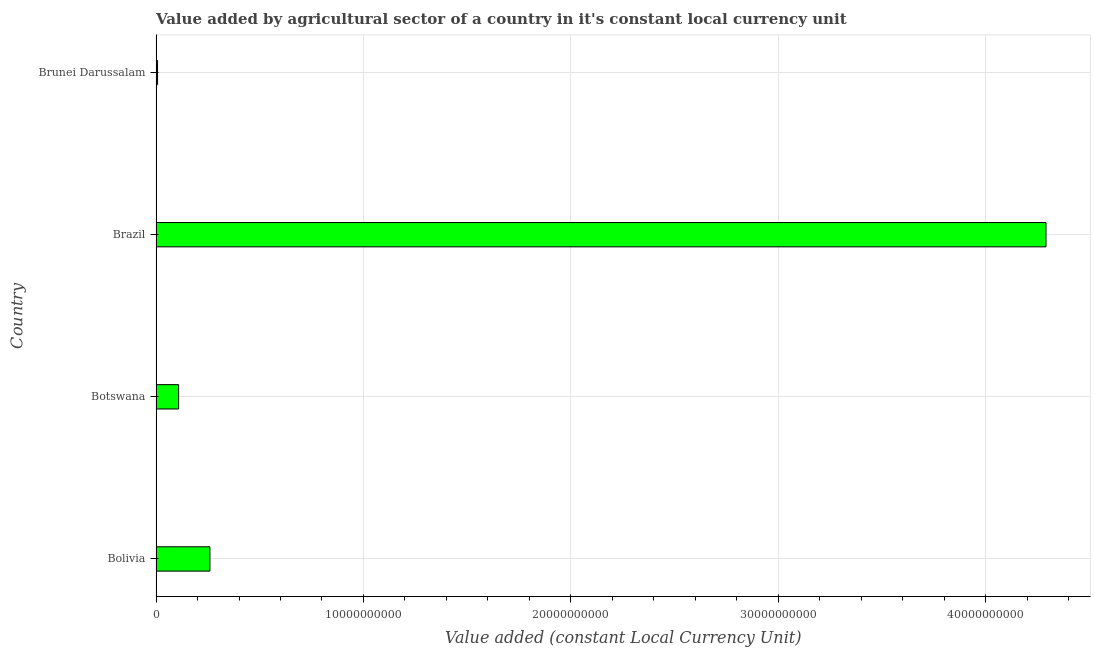What is the title of the graph?
Ensure brevity in your answer.  Value added by agricultural sector of a country in it's constant local currency unit. What is the label or title of the X-axis?
Ensure brevity in your answer.  Value added (constant Local Currency Unit). What is the label or title of the Y-axis?
Provide a succinct answer. Country. What is the value added by agriculture sector in Bolivia?
Provide a short and direct response. 2.60e+09. Across all countries, what is the maximum value added by agriculture sector?
Give a very brief answer. 4.29e+1. Across all countries, what is the minimum value added by agriculture sector?
Provide a succinct answer. 7.34e+07. In which country was the value added by agriculture sector minimum?
Your answer should be very brief. Brunei Darussalam. What is the sum of the value added by agriculture sector?
Your answer should be compact. 4.67e+1. What is the difference between the value added by agriculture sector in Brazil and Brunei Darussalam?
Ensure brevity in your answer.  4.28e+1. What is the average value added by agriculture sector per country?
Provide a succinct answer. 1.17e+1. What is the median value added by agriculture sector?
Your answer should be very brief. 1.84e+09. In how many countries, is the value added by agriculture sector greater than 20000000000 LCU?
Keep it short and to the point. 1. What is the ratio of the value added by agriculture sector in Botswana to that in Brazil?
Ensure brevity in your answer.  0.03. What is the difference between the highest and the second highest value added by agriculture sector?
Provide a succinct answer. 4.03e+1. What is the difference between the highest and the lowest value added by agriculture sector?
Your response must be concise. 4.28e+1. In how many countries, is the value added by agriculture sector greater than the average value added by agriculture sector taken over all countries?
Provide a succinct answer. 1. How many bars are there?
Keep it short and to the point. 4. Are the values on the major ticks of X-axis written in scientific E-notation?
Your answer should be very brief. No. What is the Value added (constant Local Currency Unit) in Bolivia?
Provide a short and direct response. 2.60e+09. What is the Value added (constant Local Currency Unit) of Botswana?
Provide a short and direct response. 1.09e+09. What is the Value added (constant Local Currency Unit) of Brazil?
Provide a succinct answer. 4.29e+1. What is the Value added (constant Local Currency Unit) of Brunei Darussalam?
Your response must be concise. 7.34e+07. What is the difference between the Value added (constant Local Currency Unit) in Bolivia and Botswana?
Make the answer very short. 1.51e+09. What is the difference between the Value added (constant Local Currency Unit) in Bolivia and Brazil?
Your answer should be compact. -4.03e+1. What is the difference between the Value added (constant Local Currency Unit) in Bolivia and Brunei Darussalam?
Offer a very short reply. 2.52e+09. What is the difference between the Value added (constant Local Currency Unit) in Botswana and Brazil?
Ensure brevity in your answer.  -4.18e+1. What is the difference between the Value added (constant Local Currency Unit) in Botswana and Brunei Darussalam?
Your answer should be compact. 1.02e+09. What is the difference between the Value added (constant Local Currency Unit) in Brazil and Brunei Darussalam?
Your answer should be very brief. 4.28e+1. What is the ratio of the Value added (constant Local Currency Unit) in Bolivia to that in Botswana?
Your answer should be compact. 2.38. What is the ratio of the Value added (constant Local Currency Unit) in Bolivia to that in Brazil?
Make the answer very short. 0.06. What is the ratio of the Value added (constant Local Currency Unit) in Bolivia to that in Brunei Darussalam?
Offer a very short reply. 35.4. What is the ratio of the Value added (constant Local Currency Unit) in Botswana to that in Brazil?
Ensure brevity in your answer.  0.03. What is the ratio of the Value added (constant Local Currency Unit) in Botswana to that in Brunei Darussalam?
Provide a short and direct response. 14.85. What is the ratio of the Value added (constant Local Currency Unit) in Brazil to that in Brunei Darussalam?
Ensure brevity in your answer.  584.6. 